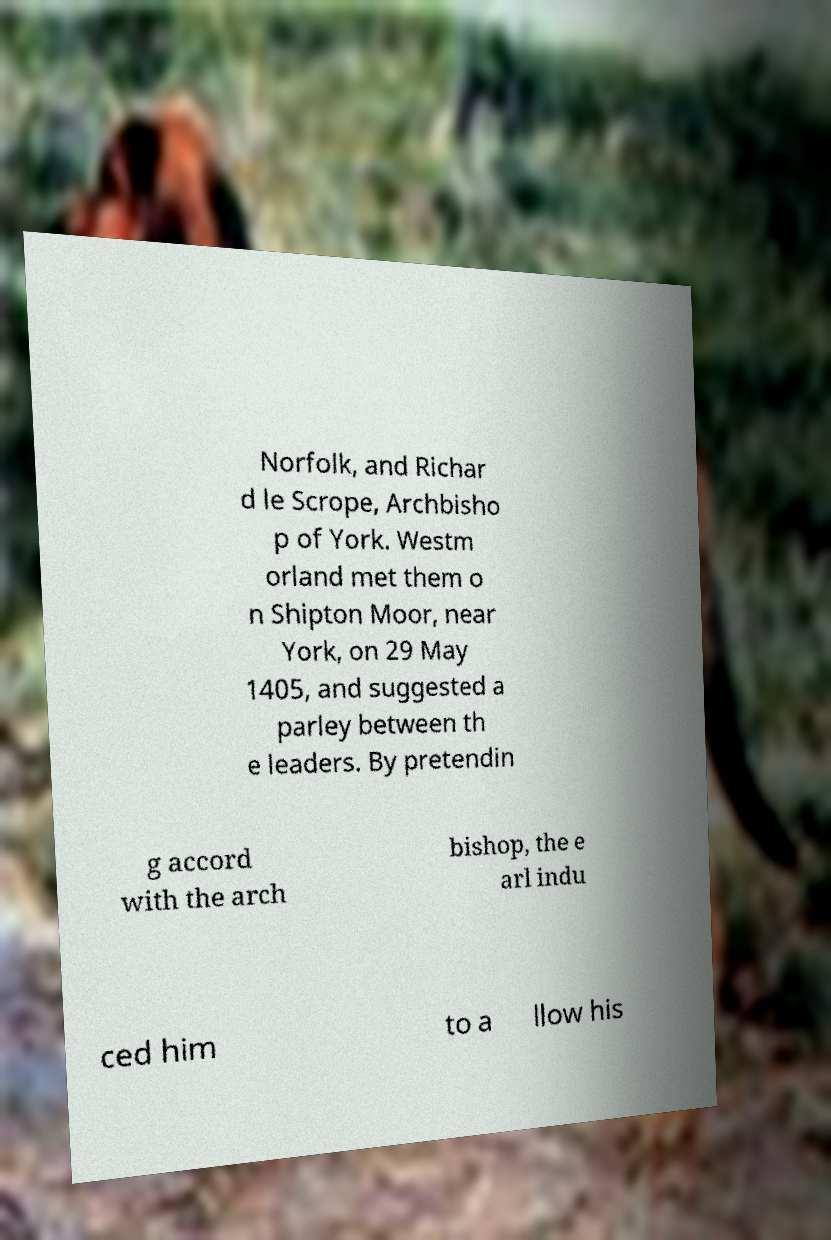Could you extract and type out the text from this image? Norfolk, and Richar d le Scrope, Archbisho p of York. Westm orland met them o n Shipton Moor, near York, on 29 May 1405, and suggested a parley between th e leaders. By pretendin g accord with the arch bishop, the e arl indu ced him to a llow his 